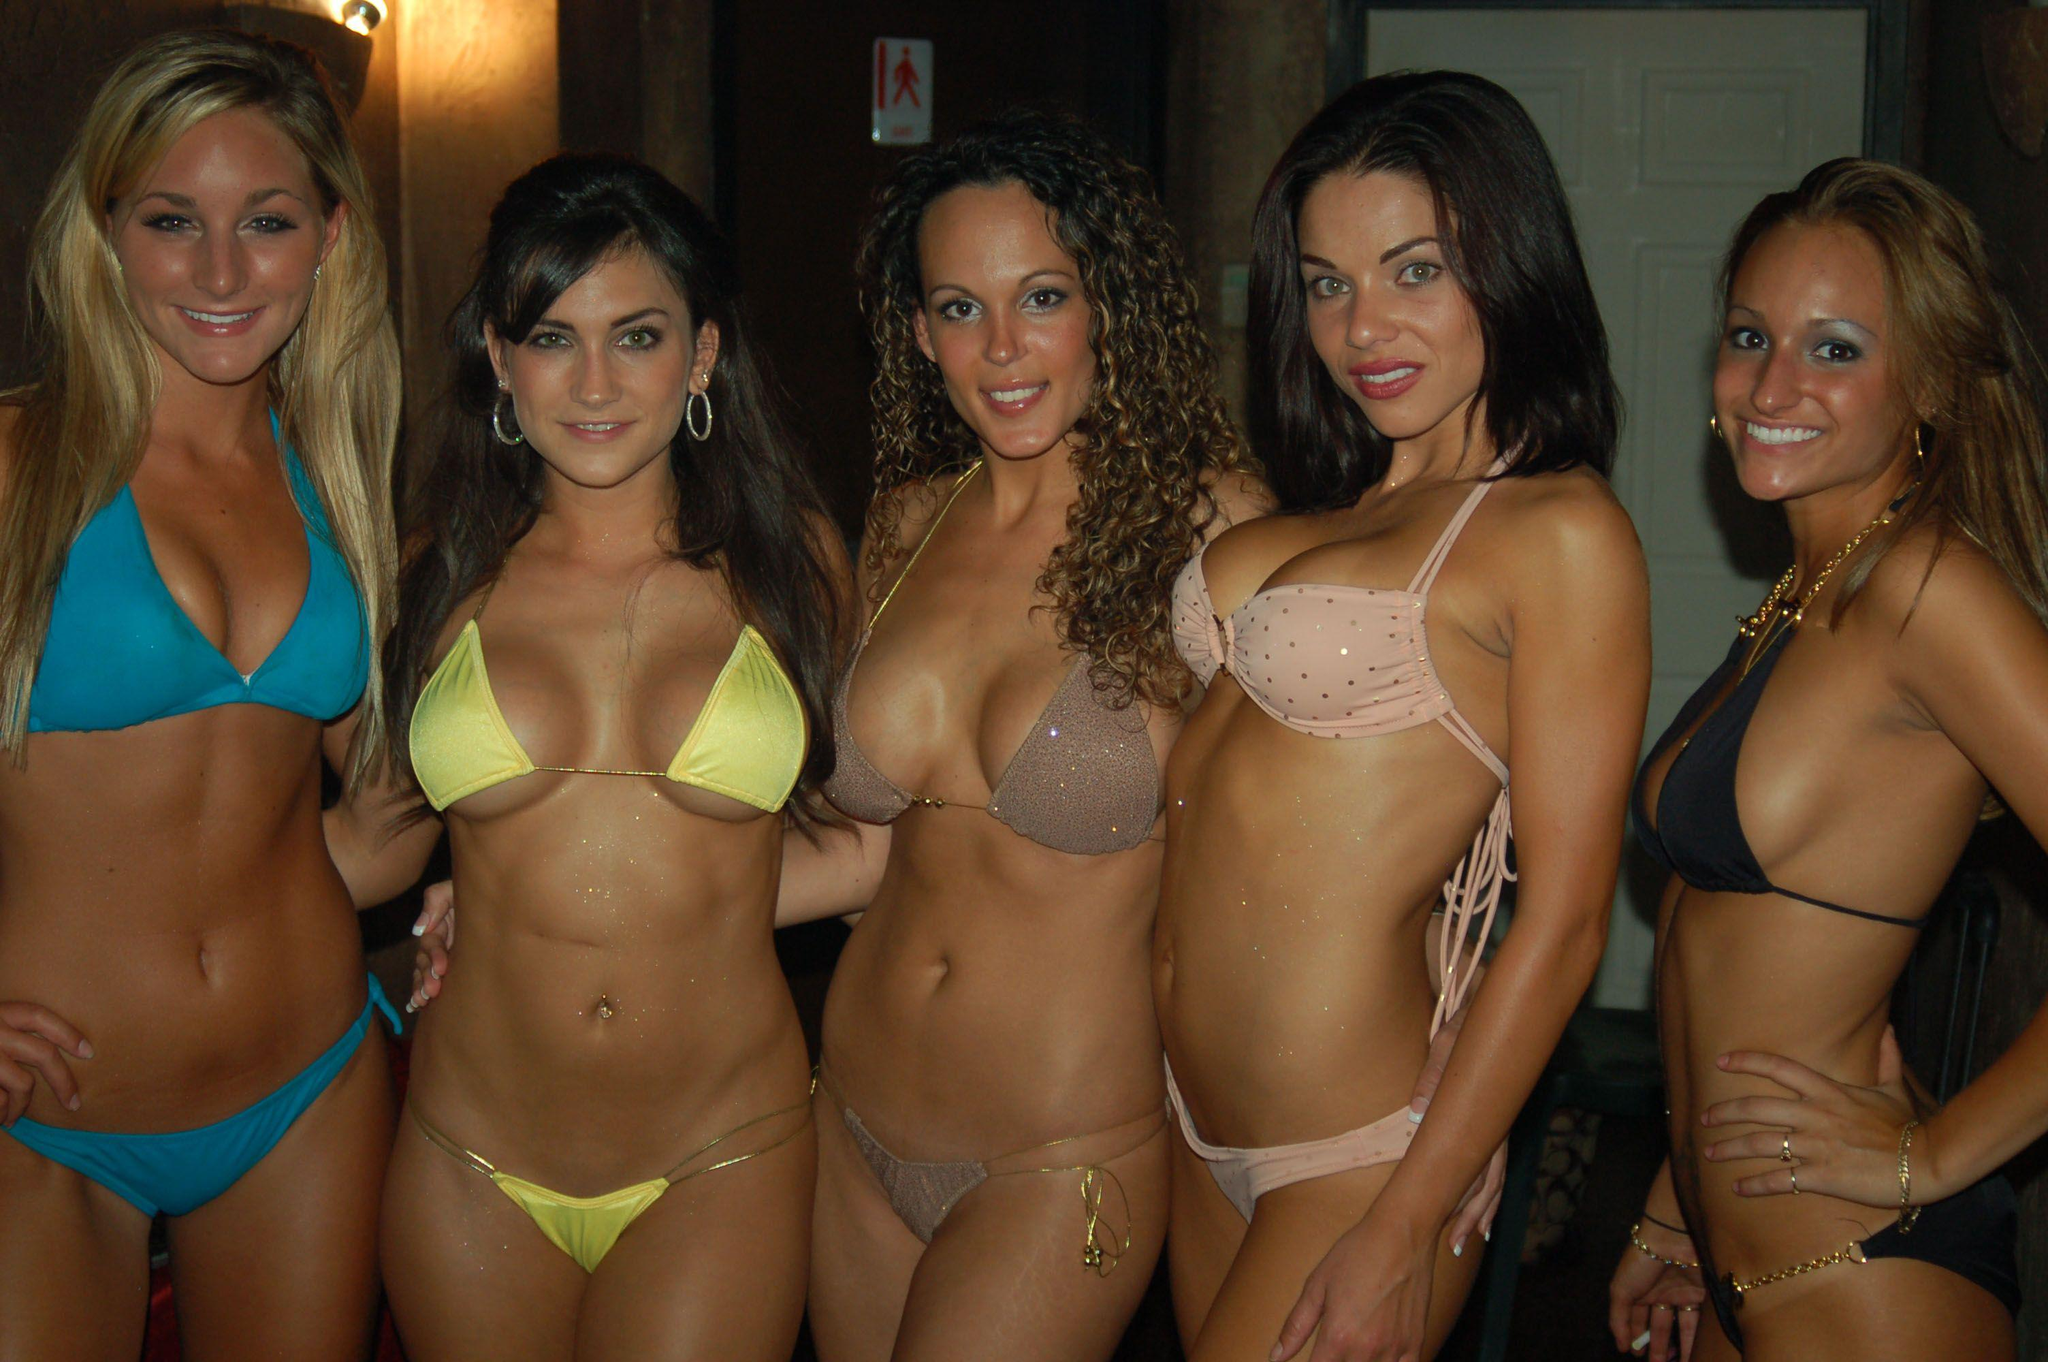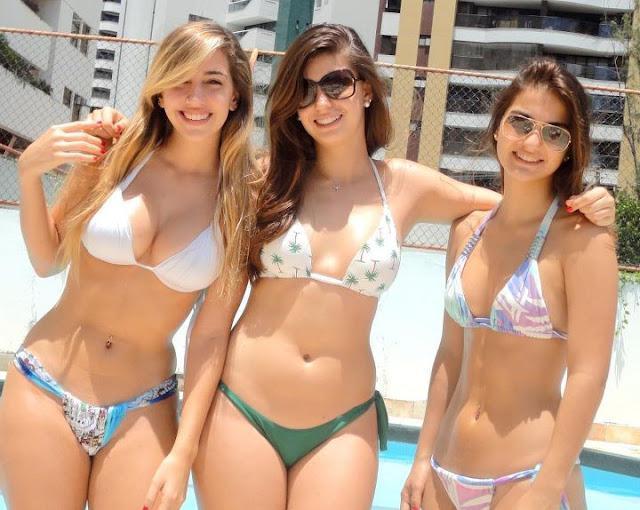The first image is the image on the left, the second image is the image on the right. Evaluate the accuracy of this statement regarding the images: "There are exactly three girls standing in one of the images.". Is it true? Answer yes or no. Yes. The first image is the image on the left, the second image is the image on the right. Given the left and right images, does the statement "In at least one image there are five women in bikinis in a row." hold true? Answer yes or no. Yes. 